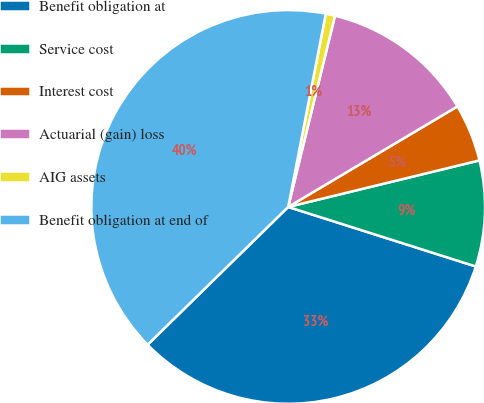Convert chart. <chart><loc_0><loc_0><loc_500><loc_500><pie_chart><fcel>Benefit obligation at<fcel>Service cost<fcel>Interest cost<fcel>Actuarial (gain) loss<fcel>AIG assets<fcel>Benefit obligation at end of<nl><fcel>32.77%<fcel>8.69%<fcel>4.73%<fcel>12.65%<fcel>0.76%<fcel>40.4%<nl></chart> 